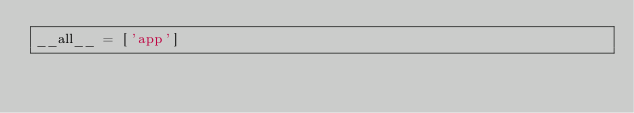Convert code to text. <code><loc_0><loc_0><loc_500><loc_500><_Python_>__all__ = ['app']
</code> 